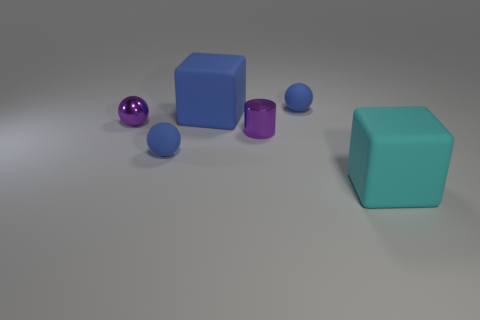There is another object that is the same shape as the big blue rubber thing; what is its size?
Provide a succinct answer. Large. Is the number of tiny purple things that are behind the purple metallic ball the same as the number of blue rubber things?
Give a very brief answer. No. Do the large thing left of the big cyan matte object and the large cyan object have the same shape?
Give a very brief answer. Yes. What shape is the large cyan object?
Ensure brevity in your answer.  Cube. There is a big cyan cube to the right of the cube behind the large object that is right of the blue rubber cube; what is its material?
Provide a succinct answer. Rubber. There is a small ball that is the same color as the small cylinder; what is it made of?
Your answer should be compact. Metal. How many objects are purple objects or metallic balls?
Ensure brevity in your answer.  2. Is the cube that is behind the large cyan thing made of the same material as the large cyan block?
Give a very brief answer. Yes. How many things are either small rubber spheres that are in front of the purple metallic ball or small red metallic things?
Give a very brief answer. 1. The other block that is made of the same material as the blue cube is what color?
Your answer should be very brief. Cyan. 